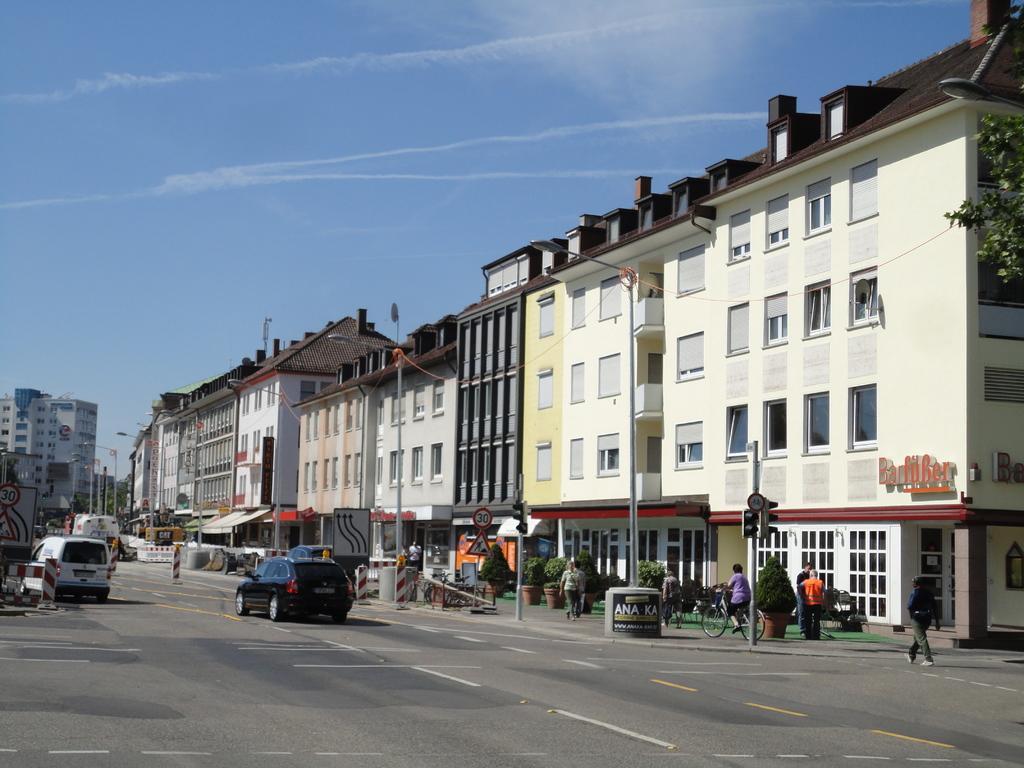Can you describe this image briefly? In this picture we can see group of people and few vehicles on the road, beside to them we can find few poles, lights, sign boards, buildings and trees. 